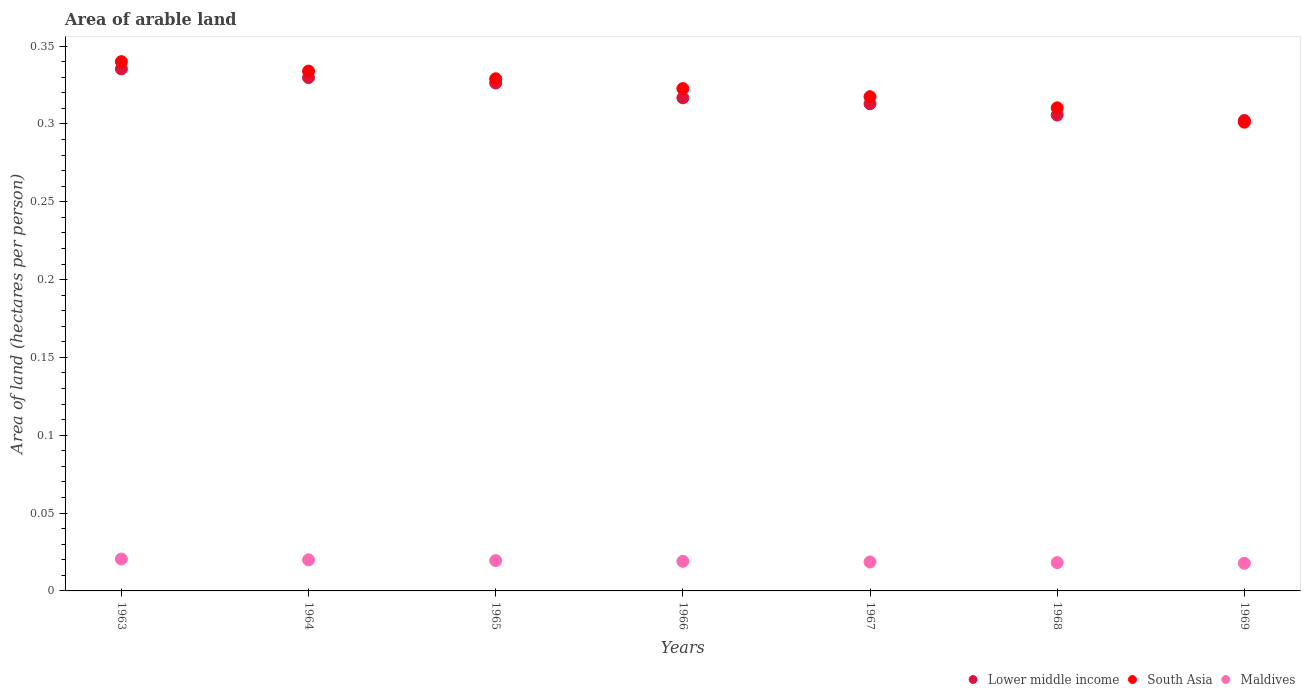What is the total arable land in Lower middle income in 1966?
Make the answer very short. 0.32. Across all years, what is the maximum total arable land in South Asia?
Your answer should be very brief. 0.34. Across all years, what is the minimum total arable land in Lower middle income?
Provide a short and direct response. 0.3. In which year was the total arable land in Maldives maximum?
Your answer should be very brief. 1963. In which year was the total arable land in Lower middle income minimum?
Ensure brevity in your answer.  1969. What is the total total arable land in South Asia in the graph?
Give a very brief answer. 2.25. What is the difference between the total arable land in Lower middle income in 1968 and that in 1969?
Your answer should be very brief. 0. What is the difference between the total arable land in South Asia in 1969 and the total arable land in Lower middle income in 1967?
Your answer should be very brief. -0.01. What is the average total arable land in Lower middle income per year?
Offer a terse response. 0.32. In the year 1964, what is the difference between the total arable land in Maldives and total arable land in South Asia?
Make the answer very short. -0.31. In how many years, is the total arable land in Lower middle income greater than 0.26 hectares per person?
Give a very brief answer. 7. What is the ratio of the total arable land in Maldives in 1965 to that in 1967?
Your answer should be compact. 1.05. Is the difference between the total arable land in Maldives in 1964 and 1967 greater than the difference between the total arable land in South Asia in 1964 and 1967?
Provide a short and direct response. No. What is the difference between the highest and the second highest total arable land in South Asia?
Keep it short and to the point. 0.01. What is the difference between the highest and the lowest total arable land in Maldives?
Your answer should be very brief. 0. In how many years, is the total arable land in Maldives greater than the average total arable land in Maldives taken over all years?
Provide a short and direct response. 3. Is it the case that in every year, the sum of the total arable land in Maldives and total arable land in South Asia  is greater than the total arable land in Lower middle income?
Offer a terse response. Yes. Are the values on the major ticks of Y-axis written in scientific E-notation?
Your response must be concise. No. Does the graph contain any zero values?
Provide a short and direct response. No. Does the graph contain grids?
Ensure brevity in your answer.  No. Where does the legend appear in the graph?
Your answer should be compact. Bottom right. What is the title of the graph?
Your answer should be very brief. Area of arable land. What is the label or title of the Y-axis?
Your answer should be compact. Area of land (hectares per person). What is the Area of land (hectares per person) of Lower middle income in 1963?
Offer a terse response. 0.34. What is the Area of land (hectares per person) of South Asia in 1963?
Offer a terse response. 0.34. What is the Area of land (hectares per person) of Maldives in 1963?
Ensure brevity in your answer.  0.02. What is the Area of land (hectares per person) in Lower middle income in 1964?
Your answer should be very brief. 0.33. What is the Area of land (hectares per person) of South Asia in 1964?
Your answer should be compact. 0.33. What is the Area of land (hectares per person) in Maldives in 1964?
Make the answer very short. 0.02. What is the Area of land (hectares per person) in Lower middle income in 1965?
Provide a succinct answer. 0.33. What is the Area of land (hectares per person) in South Asia in 1965?
Keep it short and to the point. 0.33. What is the Area of land (hectares per person) of Maldives in 1965?
Your answer should be very brief. 0.02. What is the Area of land (hectares per person) in Lower middle income in 1966?
Offer a terse response. 0.32. What is the Area of land (hectares per person) in South Asia in 1966?
Give a very brief answer. 0.32. What is the Area of land (hectares per person) of Maldives in 1966?
Make the answer very short. 0.02. What is the Area of land (hectares per person) in Lower middle income in 1967?
Offer a very short reply. 0.31. What is the Area of land (hectares per person) of South Asia in 1967?
Your response must be concise. 0.32. What is the Area of land (hectares per person) in Maldives in 1967?
Make the answer very short. 0.02. What is the Area of land (hectares per person) of Lower middle income in 1968?
Provide a succinct answer. 0.31. What is the Area of land (hectares per person) of South Asia in 1968?
Provide a succinct answer. 0.31. What is the Area of land (hectares per person) of Maldives in 1968?
Provide a succinct answer. 0.02. What is the Area of land (hectares per person) of Lower middle income in 1969?
Make the answer very short. 0.3. What is the Area of land (hectares per person) of South Asia in 1969?
Your response must be concise. 0.3. What is the Area of land (hectares per person) of Maldives in 1969?
Keep it short and to the point. 0.02. Across all years, what is the maximum Area of land (hectares per person) in Lower middle income?
Your response must be concise. 0.34. Across all years, what is the maximum Area of land (hectares per person) of South Asia?
Your answer should be compact. 0.34. Across all years, what is the maximum Area of land (hectares per person) in Maldives?
Keep it short and to the point. 0.02. Across all years, what is the minimum Area of land (hectares per person) in Lower middle income?
Your response must be concise. 0.3. Across all years, what is the minimum Area of land (hectares per person) of South Asia?
Your answer should be very brief. 0.3. Across all years, what is the minimum Area of land (hectares per person) in Maldives?
Your answer should be compact. 0.02. What is the total Area of land (hectares per person) in Lower middle income in the graph?
Your answer should be very brief. 2.23. What is the total Area of land (hectares per person) of South Asia in the graph?
Provide a succinct answer. 2.25. What is the total Area of land (hectares per person) of Maldives in the graph?
Provide a succinct answer. 0.13. What is the difference between the Area of land (hectares per person) in Lower middle income in 1963 and that in 1964?
Offer a terse response. 0.01. What is the difference between the Area of land (hectares per person) in South Asia in 1963 and that in 1964?
Ensure brevity in your answer.  0.01. What is the difference between the Area of land (hectares per person) of Maldives in 1963 and that in 1964?
Make the answer very short. 0. What is the difference between the Area of land (hectares per person) of Lower middle income in 1963 and that in 1965?
Keep it short and to the point. 0.01. What is the difference between the Area of land (hectares per person) in South Asia in 1963 and that in 1965?
Provide a short and direct response. 0.01. What is the difference between the Area of land (hectares per person) in Maldives in 1963 and that in 1965?
Your answer should be compact. 0. What is the difference between the Area of land (hectares per person) of Lower middle income in 1963 and that in 1966?
Your answer should be very brief. 0.02. What is the difference between the Area of land (hectares per person) of South Asia in 1963 and that in 1966?
Ensure brevity in your answer.  0.02. What is the difference between the Area of land (hectares per person) in Maldives in 1963 and that in 1966?
Provide a short and direct response. 0. What is the difference between the Area of land (hectares per person) of Lower middle income in 1963 and that in 1967?
Ensure brevity in your answer.  0.02. What is the difference between the Area of land (hectares per person) in South Asia in 1963 and that in 1967?
Keep it short and to the point. 0.02. What is the difference between the Area of land (hectares per person) in Maldives in 1963 and that in 1967?
Your answer should be very brief. 0. What is the difference between the Area of land (hectares per person) of Lower middle income in 1963 and that in 1968?
Provide a short and direct response. 0.03. What is the difference between the Area of land (hectares per person) in South Asia in 1963 and that in 1968?
Provide a short and direct response. 0.03. What is the difference between the Area of land (hectares per person) in Maldives in 1963 and that in 1968?
Ensure brevity in your answer.  0. What is the difference between the Area of land (hectares per person) in Lower middle income in 1963 and that in 1969?
Provide a short and direct response. 0.03. What is the difference between the Area of land (hectares per person) in South Asia in 1963 and that in 1969?
Ensure brevity in your answer.  0.04. What is the difference between the Area of land (hectares per person) in Maldives in 1963 and that in 1969?
Your answer should be very brief. 0. What is the difference between the Area of land (hectares per person) of Lower middle income in 1964 and that in 1965?
Give a very brief answer. 0. What is the difference between the Area of land (hectares per person) of South Asia in 1964 and that in 1965?
Ensure brevity in your answer.  0. What is the difference between the Area of land (hectares per person) in Maldives in 1964 and that in 1965?
Give a very brief answer. 0. What is the difference between the Area of land (hectares per person) of Lower middle income in 1964 and that in 1966?
Your answer should be very brief. 0.01. What is the difference between the Area of land (hectares per person) of South Asia in 1964 and that in 1966?
Your answer should be compact. 0.01. What is the difference between the Area of land (hectares per person) in Maldives in 1964 and that in 1966?
Offer a very short reply. 0. What is the difference between the Area of land (hectares per person) of Lower middle income in 1964 and that in 1967?
Your response must be concise. 0.02. What is the difference between the Area of land (hectares per person) of South Asia in 1964 and that in 1967?
Your response must be concise. 0.02. What is the difference between the Area of land (hectares per person) of Maldives in 1964 and that in 1967?
Your answer should be very brief. 0. What is the difference between the Area of land (hectares per person) of Lower middle income in 1964 and that in 1968?
Your answer should be compact. 0.02. What is the difference between the Area of land (hectares per person) of South Asia in 1964 and that in 1968?
Ensure brevity in your answer.  0.02. What is the difference between the Area of land (hectares per person) in Maldives in 1964 and that in 1968?
Make the answer very short. 0. What is the difference between the Area of land (hectares per person) in Lower middle income in 1964 and that in 1969?
Ensure brevity in your answer.  0.03. What is the difference between the Area of land (hectares per person) of South Asia in 1964 and that in 1969?
Provide a succinct answer. 0.03. What is the difference between the Area of land (hectares per person) in Maldives in 1964 and that in 1969?
Offer a very short reply. 0. What is the difference between the Area of land (hectares per person) in Lower middle income in 1965 and that in 1966?
Make the answer very short. 0.01. What is the difference between the Area of land (hectares per person) of South Asia in 1965 and that in 1966?
Provide a short and direct response. 0.01. What is the difference between the Area of land (hectares per person) in Lower middle income in 1965 and that in 1967?
Offer a terse response. 0.01. What is the difference between the Area of land (hectares per person) in South Asia in 1965 and that in 1967?
Your response must be concise. 0.01. What is the difference between the Area of land (hectares per person) of Maldives in 1965 and that in 1967?
Offer a very short reply. 0. What is the difference between the Area of land (hectares per person) of Lower middle income in 1965 and that in 1968?
Provide a short and direct response. 0.02. What is the difference between the Area of land (hectares per person) of South Asia in 1965 and that in 1968?
Ensure brevity in your answer.  0.02. What is the difference between the Area of land (hectares per person) of Maldives in 1965 and that in 1968?
Make the answer very short. 0. What is the difference between the Area of land (hectares per person) in Lower middle income in 1965 and that in 1969?
Offer a terse response. 0.02. What is the difference between the Area of land (hectares per person) of South Asia in 1965 and that in 1969?
Your response must be concise. 0.03. What is the difference between the Area of land (hectares per person) of Maldives in 1965 and that in 1969?
Provide a short and direct response. 0. What is the difference between the Area of land (hectares per person) of Lower middle income in 1966 and that in 1967?
Give a very brief answer. 0. What is the difference between the Area of land (hectares per person) of South Asia in 1966 and that in 1967?
Provide a succinct answer. 0.01. What is the difference between the Area of land (hectares per person) in Maldives in 1966 and that in 1967?
Offer a terse response. 0. What is the difference between the Area of land (hectares per person) in Lower middle income in 1966 and that in 1968?
Make the answer very short. 0.01. What is the difference between the Area of land (hectares per person) of South Asia in 1966 and that in 1968?
Keep it short and to the point. 0.01. What is the difference between the Area of land (hectares per person) of Maldives in 1966 and that in 1968?
Provide a short and direct response. 0. What is the difference between the Area of land (hectares per person) in Lower middle income in 1966 and that in 1969?
Provide a short and direct response. 0.01. What is the difference between the Area of land (hectares per person) in South Asia in 1966 and that in 1969?
Your answer should be very brief. 0.02. What is the difference between the Area of land (hectares per person) of Maldives in 1966 and that in 1969?
Offer a very short reply. 0. What is the difference between the Area of land (hectares per person) of Lower middle income in 1967 and that in 1968?
Keep it short and to the point. 0.01. What is the difference between the Area of land (hectares per person) in South Asia in 1967 and that in 1968?
Your response must be concise. 0.01. What is the difference between the Area of land (hectares per person) of Maldives in 1967 and that in 1968?
Provide a short and direct response. 0. What is the difference between the Area of land (hectares per person) of Lower middle income in 1967 and that in 1969?
Your answer should be very brief. 0.01. What is the difference between the Area of land (hectares per person) of South Asia in 1967 and that in 1969?
Offer a terse response. 0.02. What is the difference between the Area of land (hectares per person) in Maldives in 1967 and that in 1969?
Your response must be concise. 0. What is the difference between the Area of land (hectares per person) in Lower middle income in 1968 and that in 1969?
Provide a short and direct response. 0. What is the difference between the Area of land (hectares per person) of South Asia in 1968 and that in 1969?
Your answer should be very brief. 0.01. What is the difference between the Area of land (hectares per person) in Lower middle income in 1963 and the Area of land (hectares per person) in South Asia in 1964?
Your response must be concise. 0. What is the difference between the Area of land (hectares per person) of Lower middle income in 1963 and the Area of land (hectares per person) of Maldives in 1964?
Provide a short and direct response. 0.32. What is the difference between the Area of land (hectares per person) in South Asia in 1963 and the Area of land (hectares per person) in Maldives in 1964?
Give a very brief answer. 0.32. What is the difference between the Area of land (hectares per person) of Lower middle income in 1963 and the Area of land (hectares per person) of South Asia in 1965?
Make the answer very short. 0.01. What is the difference between the Area of land (hectares per person) in Lower middle income in 1963 and the Area of land (hectares per person) in Maldives in 1965?
Your response must be concise. 0.32. What is the difference between the Area of land (hectares per person) in South Asia in 1963 and the Area of land (hectares per person) in Maldives in 1965?
Ensure brevity in your answer.  0.32. What is the difference between the Area of land (hectares per person) in Lower middle income in 1963 and the Area of land (hectares per person) in South Asia in 1966?
Your response must be concise. 0.01. What is the difference between the Area of land (hectares per person) of Lower middle income in 1963 and the Area of land (hectares per person) of Maldives in 1966?
Your response must be concise. 0.32. What is the difference between the Area of land (hectares per person) of South Asia in 1963 and the Area of land (hectares per person) of Maldives in 1966?
Give a very brief answer. 0.32. What is the difference between the Area of land (hectares per person) in Lower middle income in 1963 and the Area of land (hectares per person) in South Asia in 1967?
Give a very brief answer. 0.02. What is the difference between the Area of land (hectares per person) of Lower middle income in 1963 and the Area of land (hectares per person) of Maldives in 1967?
Your answer should be compact. 0.32. What is the difference between the Area of land (hectares per person) of South Asia in 1963 and the Area of land (hectares per person) of Maldives in 1967?
Offer a very short reply. 0.32. What is the difference between the Area of land (hectares per person) of Lower middle income in 1963 and the Area of land (hectares per person) of South Asia in 1968?
Offer a terse response. 0.03. What is the difference between the Area of land (hectares per person) in Lower middle income in 1963 and the Area of land (hectares per person) in Maldives in 1968?
Your answer should be compact. 0.32. What is the difference between the Area of land (hectares per person) of South Asia in 1963 and the Area of land (hectares per person) of Maldives in 1968?
Your answer should be very brief. 0.32. What is the difference between the Area of land (hectares per person) in Lower middle income in 1963 and the Area of land (hectares per person) in South Asia in 1969?
Your answer should be compact. 0.03. What is the difference between the Area of land (hectares per person) in Lower middle income in 1963 and the Area of land (hectares per person) in Maldives in 1969?
Ensure brevity in your answer.  0.32. What is the difference between the Area of land (hectares per person) of South Asia in 1963 and the Area of land (hectares per person) of Maldives in 1969?
Your response must be concise. 0.32. What is the difference between the Area of land (hectares per person) in Lower middle income in 1964 and the Area of land (hectares per person) in South Asia in 1965?
Provide a short and direct response. 0. What is the difference between the Area of land (hectares per person) of Lower middle income in 1964 and the Area of land (hectares per person) of Maldives in 1965?
Provide a short and direct response. 0.31. What is the difference between the Area of land (hectares per person) in South Asia in 1964 and the Area of land (hectares per person) in Maldives in 1965?
Offer a terse response. 0.31. What is the difference between the Area of land (hectares per person) of Lower middle income in 1964 and the Area of land (hectares per person) of South Asia in 1966?
Keep it short and to the point. 0.01. What is the difference between the Area of land (hectares per person) of Lower middle income in 1964 and the Area of land (hectares per person) of Maldives in 1966?
Ensure brevity in your answer.  0.31. What is the difference between the Area of land (hectares per person) of South Asia in 1964 and the Area of land (hectares per person) of Maldives in 1966?
Provide a succinct answer. 0.31. What is the difference between the Area of land (hectares per person) of Lower middle income in 1964 and the Area of land (hectares per person) of South Asia in 1967?
Provide a succinct answer. 0.01. What is the difference between the Area of land (hectares per person) of Lower middle income in 1964 and the Area of land (hectares per person) of Maldives in 1967?
Keep it short and to the point. 0.31. What is the difference between the Area of land (hectares per person) of South Asia in 1964 and the Area of land (hectares per person) of Maldives in 1967?
Offer a terse response. 0.32. What is the difference between the Area of land (hectares per person) in Lower middle income in 1964 and the Area of land (hectares per person) in South Asia in 1968?
Offer a terse response. 0.02. What is the difference between the Area of land (hectares per person) in Lower middle income in 1964 and the Area of land (hectares per person) in Maldives in 1968?
Provide a succinct answer. 0.31. What is the difference between the Area of land (hectares per person) in South Asia in 1964 and the Area of land (hectares per person) in Maldives in 1968?
Your answer should be very brief. 0.32. What is the difference between the Area of land (hectares per person) of Lower middle income in 1964 and the Area of land (hectares per person) of South Asia in 1969?
Make the answer very short. 0.03. What is the difference between the Area of land (hectares per person) of Lower middle income in 1964 and the Area of land (hectares per person) of Maldives in 1969?
Provide a succinct answer. 0.31. What is the difference between the Area of land (hectares per person) in South Asia in 1964 and the Area of land (hectares per person) in Maldives in 1969?
Keep it short and to the point. 0.32. What is the difference between the Area of land (hectares per person) of Lower middle income in 1965 and the Area of land (hectares per person) of South Asia in 1966?
Ensure brevity in your answer.  0. What is the difference between the Area of land (hectares per person) of Lower middle income in 1965 and the Area of land (hectares per person) of Maldives in 1966?
Provide a short and direct response. 0.31. What is the difference between the Area of land (hectares per person) in South Asia in 1965 and the Area of land (hectares per person) in Maldives in 1966?
Provide a short and direct response. 0.31. What is the difference between the Area of land (hectares per person) in Lower middle income in 1965 and the Area of land (hectares per person) in South Asia in 1967?
Ensure brevity in your answer.  0.01. What is the difference between the Area of land (hectares per person) of Lower middle income in 1965 and the Area of land (hectares per person) of Maldives in 1967?
Offer a terse response. 0.31. What is the difference between the Area of land (hectares per person) in South Asia in 1965 and the Area of land (hectares per person) in Maldives in 1967?
Provide a short and direct response. 0.31. What is the difference between the Area of land (hectares per person) of Lower middle income in 1965 and the Area of land (hectares per person) of South Asia in 1968?
Keep it short and to the point. 0.02. What is the difference between the Area of land (hectares per person) in Lower middle income in 1965 and the Area of land (hectares per person) in Maldives in 1968?
Your answer should be compact. 0.31. What is the difference between the Area of land (hectares per person) of South Asia in 1965 and the Area of land (hectares per person) of Maldives in 1968?
Provide a short and direct response. 0.31. What is the difference between the Area of land (hectares per person) of Lower middle income in 1965 and the Area of land (hectares per person) of South Asia in 1969?
Give a very brief answer. 0.03. What is the difference between the Area of land (hectares per person) of Lower middle income in 1965 and the Area of land (hectares per person) of Maldives in 1969?
Your answer should be compact. 0.31. What is the difference between the Area of land (hectares per person) in South Asia in 1965 and the Area of land (hectares per person) in Maldives in 1969?
Offer a very short reply. 0.31. What is the difference between the Area of land (hectares per person) in Lower middle income in 1966 and the Area of land (hectares per person) in South Asia in 1967?
Ensure brevity in your answer.  -0. What is the difference between the Area of land (hectares per person) of Lower middle income in 1966 and the Area of land (hectares per person) of Maldives in 1967?
Offer a terse response. 0.3. What is the difference between the Area of land (hectares per person) of South Asia in 1966 and the Area of land (hectares per person) of Maldives in 1967?
Your answer should be very brief. 0.3. What is the difference between the Area of land (hectares per person) in Lower middle income in 1966 and the Area of land (hectares per person) in South Asia in 1968?
Ensure brevity in your answer.  0.01. What is the difference between the Area of land (hectares per person) in Lower middle income in 1966 and the Area of land (hectares per person) in Maldives in 1968?
Offer a terse response. 0.3. What is the difference between the Area of land (hectares per person) in South Asia in 1966 and the Area of land (hectares per person) in Maldives in 1968?
Offer a terse response. 0.3. What is the difference between the Area of land (hectares per person) of Lower middle income in 1966 and the Area of land (hectares per person) of South Asia in 1969?
Offer a very short reply. 0.02. What is the difference between the Area of land (hectares per person) in Lower middle income in 1966 and the Area of land (hectares per person) in Maldives in 1969?
Your response must be concise. 0.3. What is the difference between the Area of land (hectares per person) in South Asia in 1966 and the Area of land (hectares per person) in Maldives in 1969?
Make the answer very short. 0.3. What is the difference between the Area of land (hectares per person) of Lower middle income in 1967 and the Area of land (hectares per person) of South Asia in 1968?
Offer a very short reply. 0. What is the difference between the Area of land (hectares per person) of Lower middle income in 1967 and the Area of land (hectares per person) of Maldives in 1968?
Ensure brevity in your answer.  0.29. What is the difference between the Area of land (hectares per person) of South Asia in 1967 and the Area of land (hectares per person) of Maldives in 1968?
Provide a short and direct response. 0.3. What is the difference between the Area of land (hectares per person) in Lower middle income in 1967 and the Area of land (hectares per person) in South Asia in 1969?
Keep it short and to the point. 0.01. What is the difference between the Area of land (hectares per person) in Lower middle income in 1967 and the Area of land (hectares per person) in Maldives in 1969?
Give a very brief answer. 0.3. What is the difference between the Area of land (hectares per person) of South Asia in 1967 and the Area of land (hectares per person) of Maldives in 1969?
Give a very brief answer. 0.3. What is the difference between the Area of land (hectares per person) in Lower middle income in 1968 and the Area of land (hectares per person) in South Asia in 1969?
Give a very brief answer. 0. What is the difference between the Area of land (hectares per person) of Lower middle income in 1968 and the Area of land (hectares per person) of Maldives in 1969?
Offer a terse response. 0.29. What is the difference between the Area of land (hectares per person) of South Asia in 1968 and the Area of land (hectares per person) of Maldives in 1969?
Ensure brevity in your answer.  0.29. What is the average Area of land (hectares per person) of Lower middle income per year?
Make the answer very short. 0.32. What is the average Area of land (hectares per person) in South Asia per year?
Keep it short and to the point. 0.32. What is the average Area of land (hectares per person) of Maldives per year?
Your answer should be compact. 0.02. In the year 1963, what is the difference between the Area of land (hectares per person) of Lower middle income and Area of land (hectares per person) of South Asia?
Offer a very short reply. -0. In the year 1963, what is the difference between the Area of land (hectares per person) of Lower middle income and Area of land (hectares per person) of Maldives?
Ensure brevity in your answer.  0.31. In the year 1963, what is the difference between the Area of land (hectares per person) in South Asia and Area of land (hectares per person) in Maldives?
Give a very brief answer. 0.32. In the year 1964, what is the difference between the Area of land (hectares per person) in Lower middle income and Area of land (hectares per person) in South Asia?
Ensure brevity in your answer.  -0. In the year 1964, what is the difference between the Area of land (hectares per person) of Lower middle income and Area of land (hectares per person) of Maldives?
Provide a short and direct response. 0.31. In the year 1964, what is the difference between the Area of land (hectares per person) of South Asia and Area of land (hectares per person) of Maldives?
Offer a terse response. 0.31. In the year 1965, what is the difference between the Area of land (hectares per person) in Lower middle income and Area of land (hectares per person) in South Asia?
Offer a terse response. -0. In the year 1965, what is the difference between the Area of land (hectares per person) of Lower middle income and Area of land (hectares per person) of Maldives?
Offer a very short reply. 0.31. In the year 1965, what is the difference between the Area of land (hectares per person) of South Asia and Area of land (hectares per person) of Maldives?
Ensure brevity in your answer.  0.31. In the year 1966, what is the difference between the Area of land (hectares per person) of Lower middle income and Area of land (hectares per person) of South Asia?
Make the answer very short. -0.01. In the year 1966, what is the difference between the Area of land (hectares per person) of Lower middle income and Area of land (hectares per person) of Maldives?
Your answer should be very brief. 0.3. In the year 1966, what is the difference between the Area of land (hectares per person) of South Asia and Area of land (hectares per person) of Maldives?
Keep it short and to the point. 0.3. In the year 1967, what is the difference between the Area of land (hectares per person) of Lower middle income and Area of land (hectares per person) of South Asia?
Keep it short and to the point. -0. In the year 1967, what is the difference between the Area of land (hectares per person) of Lower middle income and Area of land (hectares per person) of Maldives?
Make the answer very short. 0.29. In the year 1967, what is the difference between the Area of land (hectares per person) in South Asia and Area of land (hectares per person) in Maldives?
Your answer should be compact. 0.3. In the year 1968, what is the difference between the Area of land (hectares per person) in Lower middle income and Area of land (hectares per person) in South Asia?
Keep it short and to the point. -0. In the year 1968, what is the difference between the Area of land (hectares per person) of Lower middle income and Area of land (hectares per person) of Maldives?
Provide a short and direct response. 0.29. In the year 1968, what is the difference between the Area of land (hectares per person) of South Asia and Area of land (hectares per person) of Maldives?
Ensure brevity in your answer.  0.29. In the year 1969, what is the difference between the Area of land (hectares per person) of Lower middle income and Area of land (hectares per person) of South Asia?
Make the answer very short. 0. In the year 1969, what is the difference between the Area of land (hectares per person) in Lower middle income and Area of land (hectares per person) in Maldives?
Your answer should be very brief. 0.28. In the year 1969, what is the difference between the Area of land (hectares per person) in South Asia and Area of land (hectares per person) in Maldives?
Offer a very short reply. 0.28. What is the ratio of the Area of land (hectares per person) in Lower middle income in 1963 to that in 1964?
Provide a succinct answer. 1.02. What is the ratio of the Area of land (hectares per person) in South Asia in 1963 to that in 1964?
Make the answer very short. 1.02. What is the ratio of the Area of land (hectares per person) in Maldives in 1963 to that in 1964?
Offer a very short reply. 1.03. What is the ratio of the Area of land (hectares per person) in Lower middle income in 1963 to that in 1965?
Your response must be concise. 1.03. What is the ratio of the Area of land (hectares per person) in South Asia in 1963 to that in 1965?
Your answer should be very brief. 1.03. What is the ratio of the Area of land (hectares per person) in Maldives in 1963 to that in 1965?
Your response must be concise. 1.05. What is the ratio of the Area of land (hectares per person) in Lower middle income in 1963 to that in 1966?
Your answer should be compact. 1.06. What is the ratio of the Area of land (hectares per person) of South Asia in 1963 to that in 1966?
Offer a terse response. 1.05. What is the ratio of the Area of land (hectares per person) in Maldives in 1963 to that in 1966?
Provide a succinct answer. 1.08. What is the ratio of the Area of land (hectares per person) in Lower middle income in 1963 to that in 1967?
Your answer should be compact. 1.07. What is the ratio of the Area of land (hectares per person) in South Asia in 1963 to that in 1967?
Offer a terse response. 1.07. What is the ratio of the Area of land (hectares per person) in Maldives in 1963 to that in 1967?
Keep it short and to the point. 1.1. What is the ratio of the Area of land (hectares per person) in Lower middle income in 1963 to that in 1968?
Ensure brevity in your answer.  1.1. What is the ratio of the Area of land (hectares per person) in South Asia in 1963 to that in 1968?
Your response must be concise. 1.1. What is the ratio of the Area of land (hectares per person) of Maldives in 1963 to that in 1968?
Offer a terse response. 1.13. What is the ratio of the Area of land (hectares per person) in Lower middle income in 1963 to that in 1969?
Your answer should be very brief. 1.11. What is the ratio of the Area of land (hectares per person) in South Asia in 1963 to that in 1969?
Your answer should be compact. 1.13. What is the ratio of the Area of land (hectares per person) of Maldives in 1963 to that in 1969?
Your answer should be compact. 1.15. What is the ratio of the Area of land (hectares per person) of Lower middle income in 1964 to that in 1965?
Your answer should be compact. 1.01. What is the ratio of the Area of land (hectares per person) in South Asia in 1964 to that in 1965?
Your answer should be compact. 1.01. What is the ratio of the Area of land (hectares per person) of Maldives in 1964 to that in 1965?
Offer a very short reply. 1.03. What is the ratio of the Area of land (hectares per person) of Lower middle income in 1964 to that in 1966?
Ensure brevity in your answer.  1.04. What is the ratio of the Area of land (hectares per person) of South Asia in 1964 to that in 1966?
Provide a succinct answer. 1.03. What is the ratio of the Area of land (hectares per person) of Maldives in 1964 to that in 1966?
Offer a terse response. 1.05. What is the ratio of the Area of land (hectares per person) of Lower middle income in 1964 to that in 1967?
Offer a terse response. 1.05. What is the ratio of the Area of land (hectares per person) of South Asia in 1964 to that in 1967?
Your answer should be very brief. 1.05. What is the ratio of the Area of land (hectares per person) of Maldives in 1964 to that in 1967?
Your response must be concise. 1.07. What is the ratio of the Area of land (hectares per person) of Lower middle income in 1964 to that in 1968?
Give a very brief answer. 1.08. What is the ratio of the Area of land (hectares per person) in South Asia in 1964 to that in 1968?
Provide a short and direct response. 1.08. What is the ratio of the Area of land (hectares per person) of Maldives in 1964 to that in 1968?
Give a very brief answer. 1.1. What is the ratio of the Area of land (hectares per person) of Lower middle income in 1964 to that in 1969?
Provide a short and direct response. 1.09. What is the ratio of the Area of land (hectares per person) in South Asia in 1964 to that in 1969?
Provide a short and direct response. 1.11. What is the ratio of the Area of land (hectares per person) in Maldives in 1964 to that in 1969?
Keep it short and to the point. 1.12. What is the ratio of the Area of land (hectares per person) of Lower middle income in 1965 to that in 1966?
Give a very brief answer. 1.03. What is the ratio of the Area of land (hectares per person) of South Asia in 1965 to that in 1966?
Give a very brief answer. 1.02. What is the ratio of the Area of land (hectares per person) of Maldives in 1965 to that in 1966?
Provide a short and direct response. 1.02. What is the ratio of the Area of land (hectares per person) of Lower middle income in 1965 to that in 1967?
Keep it short and to the point. 1.04. What is the ratio of the Area of land (hectares per person) of South Asia in 1965 to that in 1967?
Your answer should be compact. 1.04. What is the ratio of the Area of land (hectares per person) of Maldives in 1965 to that in 1967?
Keep it short and to the point. 1.05. What is the ratio of the Area of land (hectares per person) of Lower middle income in 1965 to that in 1968?
Make the answer very short. 1.07. What is the ratio of the Area of land (hectares per person) in South Asia in 1965 to that in 1968?
Offer a terse response. 1.06. What is the ratio of the Area of land (hectares per person) in Maldives in 1965 to that in 1968?
Offer a very short reply. 1.07. What is the ratio of the Area of land (hectares per person) in Lower middle income in 1965 to that in 1969?
Offer a terse response. 1.08. What is the ratio of the Area of land (hectares per person) in South Asia in 1965 to that in 1969?
Your response must be concise. 1.09. What is the ratio of the Area of land (hectares per person) of Maldives in 1965 to that in 1969?
Offer a terse response. 1.1. What is the ratio of the Area of land (hectares per person) in Lower middle income in 1966 to that in 1967?
Keep it short and to the point. 1.01. What is the ratio of the Area of land (hectares per person) in South Asia in 1966 to that in 1967?
Ensure brevity in your answer.  1.02. What is the ratio of the Area of land (hectares per person) in Maldives in 1966 to that in 1967?
Make the answer very short. 1.02. What is the ratio of the Area of land (hectares per person) of Lower middle income in 1966 to that in 1968?
Offer a terse response. 1.04. What is the ratio of the Area of land (hectares per person) in South Asia in 1966 to that in 1968?
Offer a terse response. 1.04. What is the ratio of the Area of land (hectares per person) of Maldives in 1966 to that in 1968?
Give a very brief answer. 1.05. What is the ratio of the Area of land (hectares per person) of Lower middle income in 1966 to that in 1969?
Give a very brief answer. 1.05. What is the ratio of the Area of land (hectares per person) of South Asia in 1966 to that in 1969?
Your answer should be compact. 1.07. What is the ratio of the Area of land (hectares per person) in Maldives in 1966 to that in 1969?
Offer a terse response. 1.07. What is the ratio of the Area of land (hectares per person) in Lower middle income in 1967 to that in 1968?
Provide a succinct answer. 1.02. What is the ratio of the Area of land (hectares per person) in South Asia in 1967 to that in 1968?
Provide a short and direct response. 1.02. What is the ratio of the Area of land (hectares per person) of Maldives in 1967 to that in 1968?
Offer a terse response. 1.02. What is the ratio of the Area of land (hectares per person) of Lower middle income in 1967 to that in 1969?
Provide a short and direct response. 1.04. What is the ratio of the Area of land (hectares per person) in South Asia in 1967 to that in 1969?
Provide a short and direct response. 1.05. What is the ratio of the Area of land (hectares per person) of Maldives in 1967 to that in 1969?
Provide a short and direct response. 1.05. What is the ratio of the Area of land (hectares per person) of Lower middle income in 1968 to that in 1969?
Your answer should be compact. 1.01. What is the ratio of the Area of land (hectares per person) of South Asia in 1968 to that in 1969?
Your answer should be compact. 1.03. What is the ratio of the Area of land (hectares per person) in Maldives in 1968 to that in 1969?
Keep it short and to the point. 1.02. What is the difference between the highest and the second highest Area of land (hectares per person) of Lower middle income?
Provide a short and direct response. 0.01. What is the difference between the highest and the second highest Area of land (hectares per person) of South Asia?
Your response must be concise. 0.01. What is the difference between the highest and the lowest Area of land (hectares per person) of Lower middle income?
Your answer should be very brief. 0.03. What is the difference between the highest and the lowest Area of land (hectares per person) of South Asia?
Keep it short and to the point. 0.04. What is the difference between the highest and the lowest Area of land (hectares per person) in Maldives?
Provide a short and direct response. 0. 